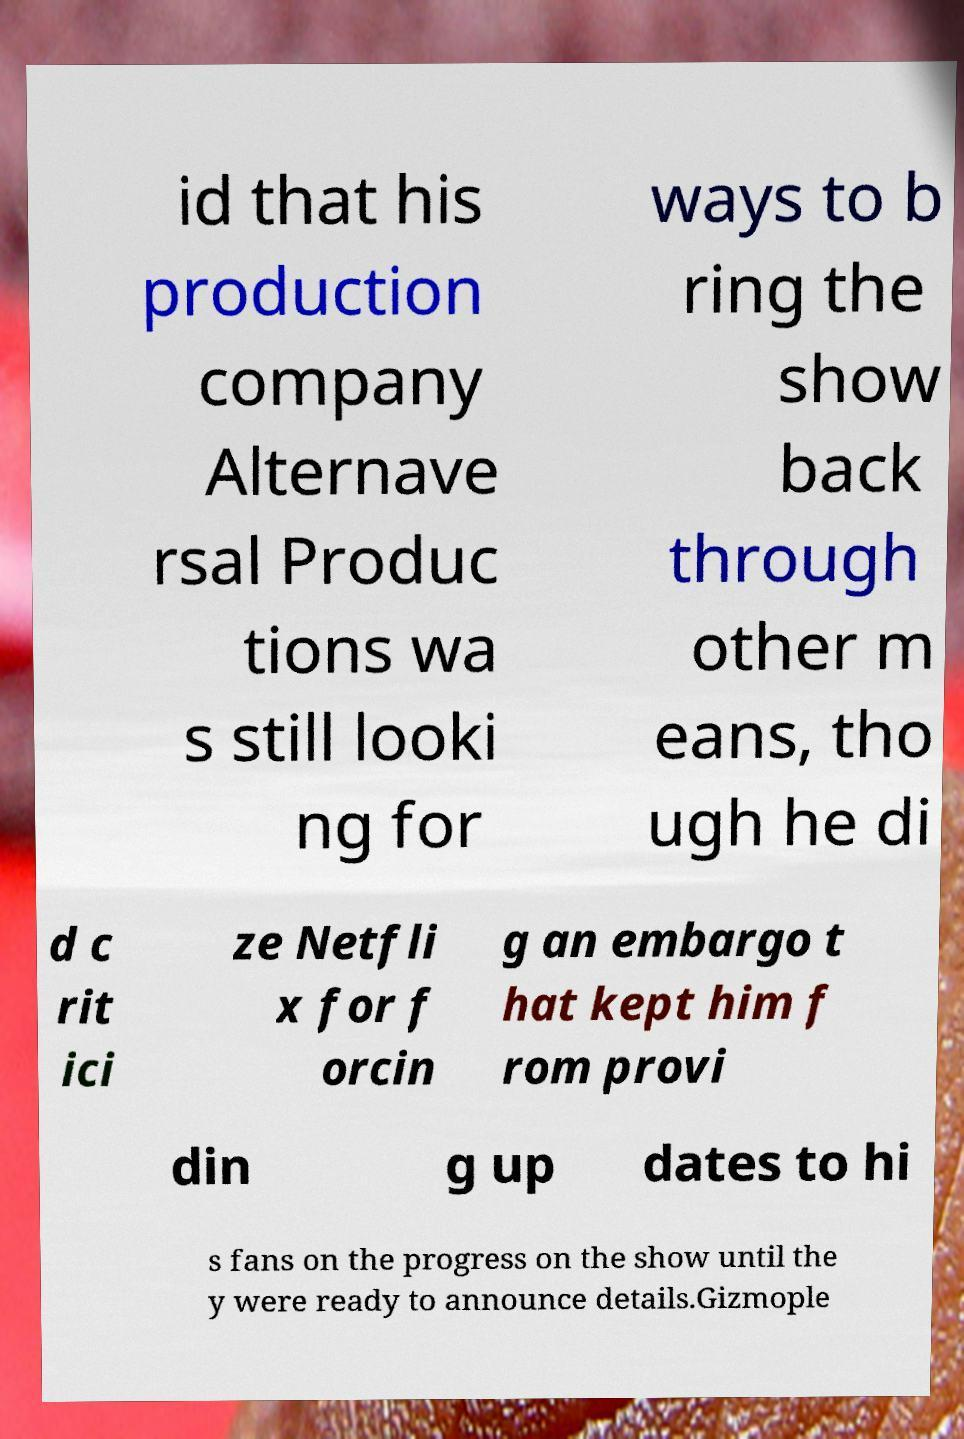For documentation purposes, I need the text within this image transcribed. Could you provide that? id that his production company Alternave rsal Produc tions wa s still looki ng for ways to b ring the show back through other m eans, tho ugh he di d c rit ici ze Netfli x for f orcin g an embargo t hat kept him f rom provi din g up dates to hi s fans on the progress on the show until the y were ready to announce details.Gizmople 